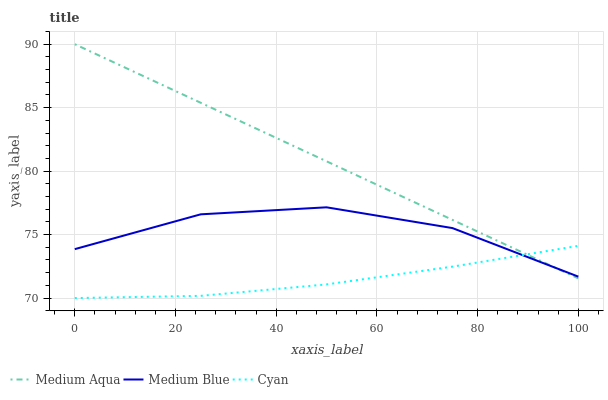Does Cyan have the minimum area under the curve?
Answer yes or no. Yes. Does Medium Aqua have the maximum area under the curve?
Answer yes or no. Yes. Does Medium Aqua have the minimum area under the curve?
Answer yes or no. No. Does Cyan have the maximum area under the curve?
Answer yes or no. No. Is Medium Aqua the smoothest?
Answer yes or no. Yes. Is Medium Blue the roughest?
Answer yes or no. Yes. Is Cyan the smoothest?
Answer yes or no. No. Is Cyan the roughest?
Answer yes or no. No. Does Cyan have the lowest value?
Answer yes or no. Yes. Does Medium Aqua have the lowest value?
Answer yes or no. No. Does Medium Aqua have the highest value?
Answer yes or no. Yes. Does Cyan have the highest value?
Answer yes or no. No. Does Medium Aqua intersect Cyan?
Answer yes or no. Yes. Is Medium Aqua less than Cyan?
Answer yes or no. No. Is Medium Aqua greater than Cyan?
Answer yes or no. No. 